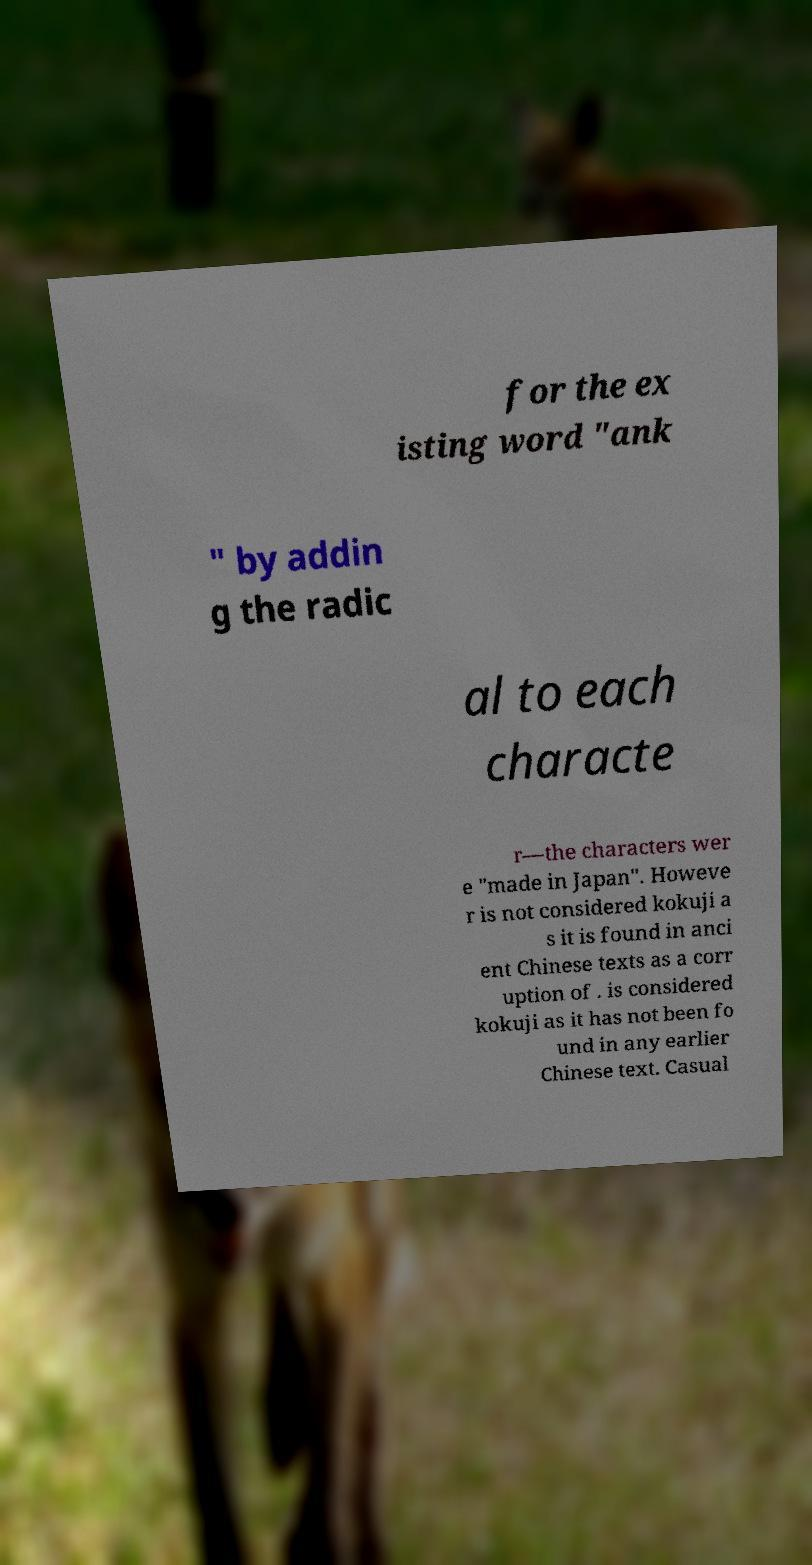Please read and relay the text visible in this image. What does it say? for the ex isting word "ank " by addin g the radic al to each characte r—the characters wer e "made in Japan". Howeve r is not considered kokuji a s it is found in anci ent Chinese texts as a corr uption of . is considered kokuji as it has not been fo und in any earlier Chinese text. Casual 